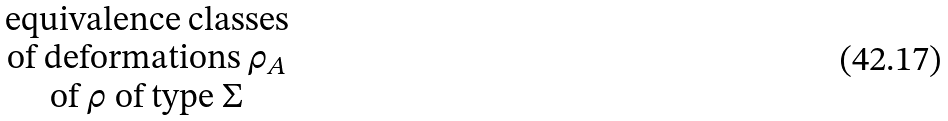<formula> <loc_0><loc_0><loc_500><loc_500>\begin{matrix} \text {equivalence classes} \\ \text {of deformations $\rho_{A}$} \\ \text {of $\overline{ }\rho$ of type $\Sigma$} \end{matrix}</formula> 